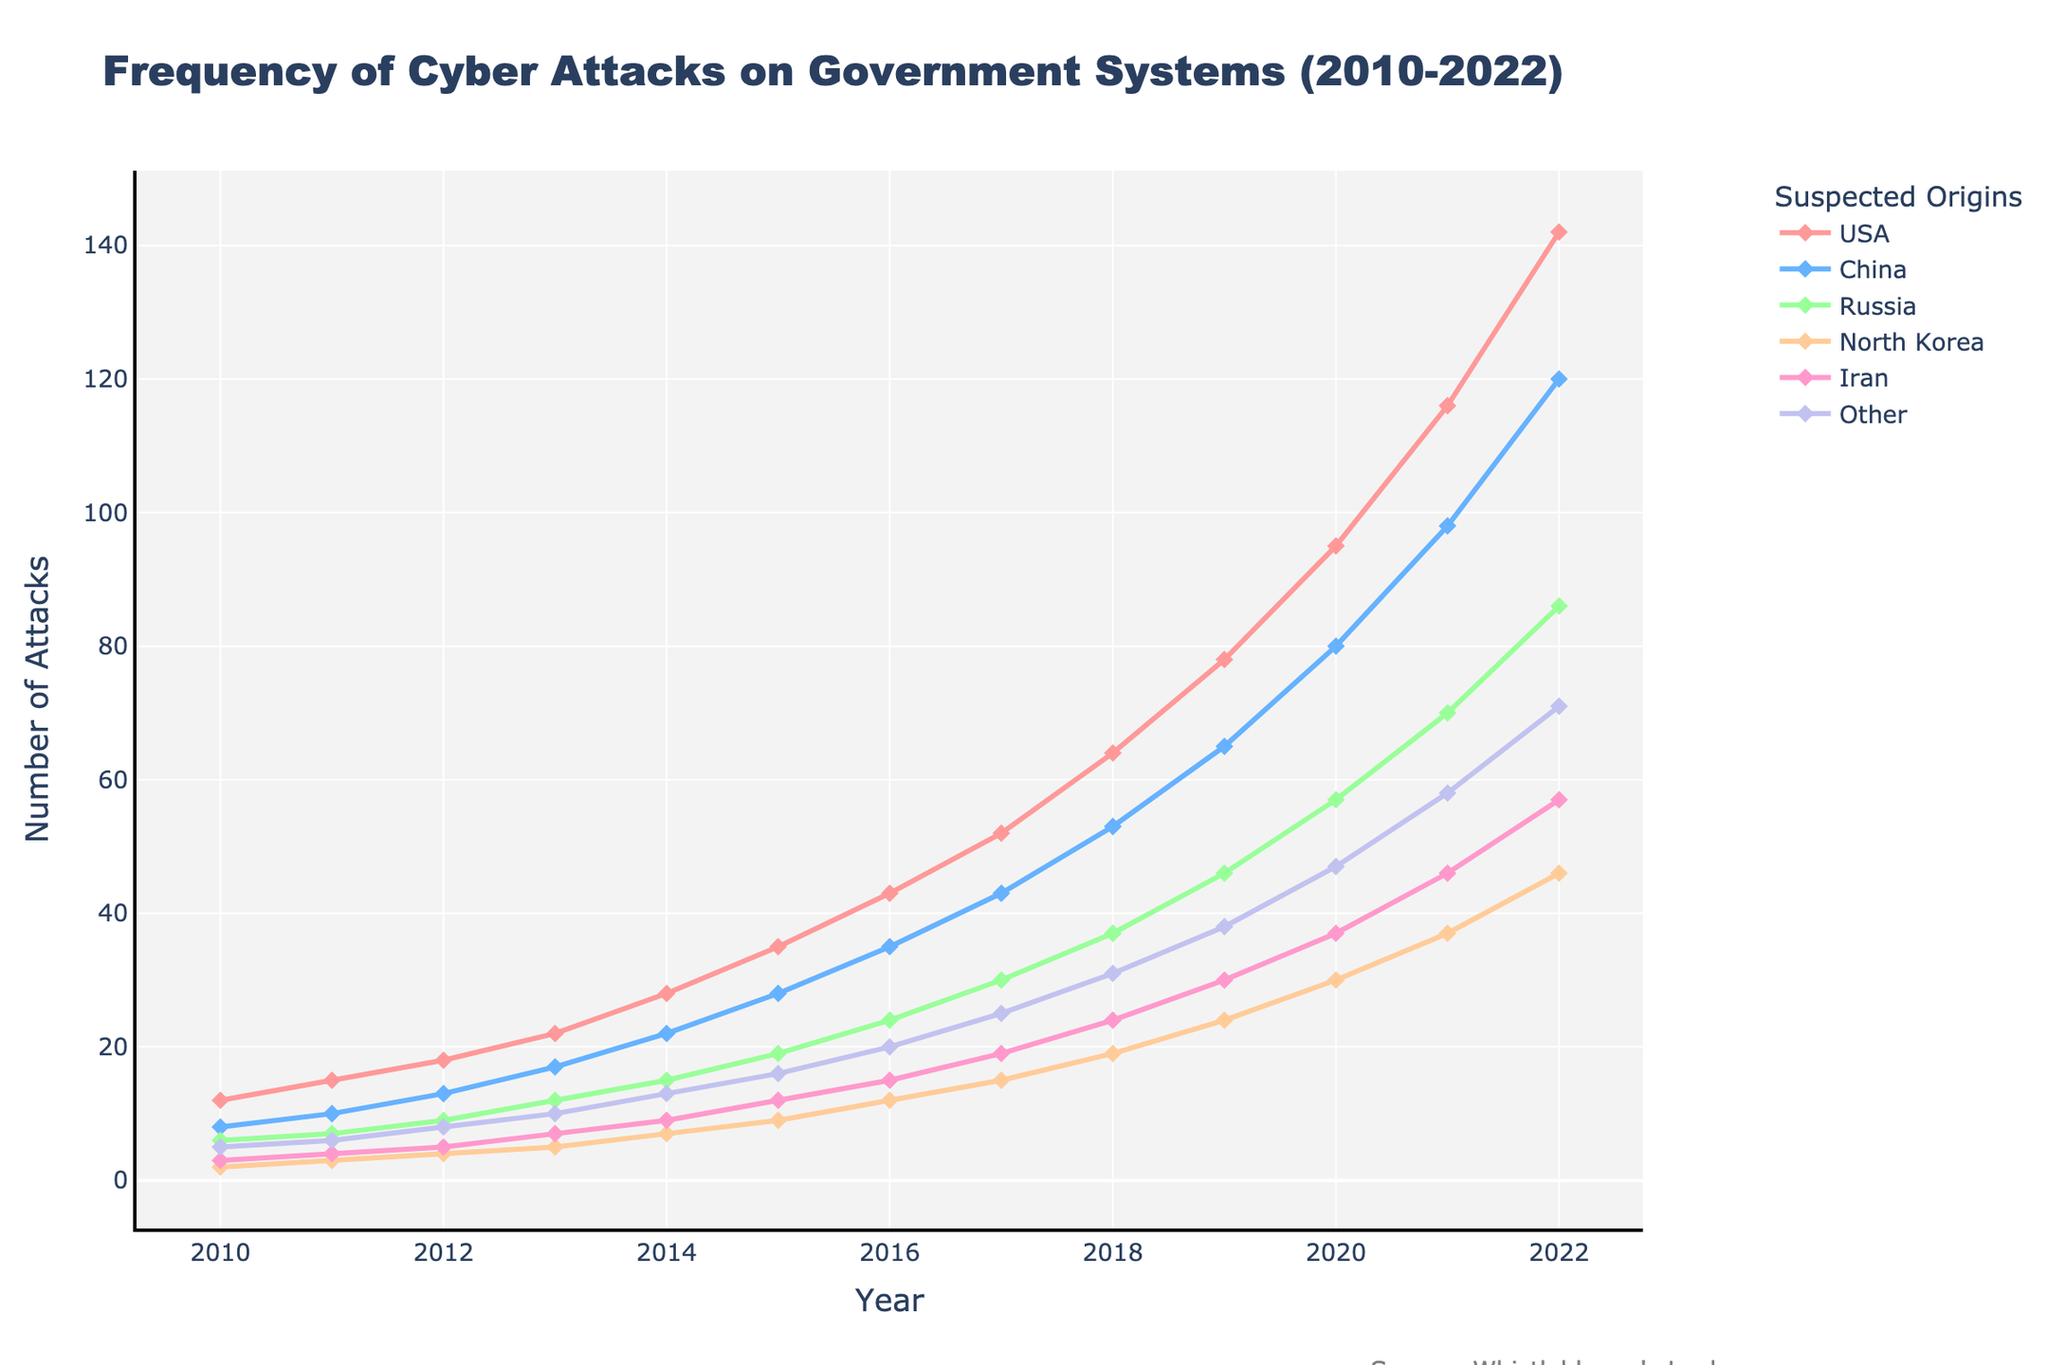Which country had the highest number of cyber attacks in 2022? The plot shows the number of attacks for each country in 2022 on the right-most side. The line labeled "USA" is the highest.
Answer: USA Between 2016 and 2018, which country showed the largest increase in the number of cyber attacks? To find the largest increase, subtract the number of attacks in 2016 from the number in 2018 for each country: USA (64-43=21), China (53-35=18), Russia (37-24=13), North Korea (19-12=7), Iran (24-15=9), Other (31-20=11). The USA has the largest increase at 21 attacks.
Answer: USA In which year did Iran surpass North Korea in the number of cyber attacks? To determine the year Iran surpassed North Korea, compare the values for each year. In 2019, Iran (30) had more attacks than North Korea (24) for the first time.
Answer: 2019 What is the average number of cyber attacks on government systems for Russia from 2010 to 2022? Add up all the values for Russia and divide by the number of years (13): (6+7+9+12+15+19+24+30+37+46+57+70+86)/13 ≈ 33.38
Answer: 33.38 Which country had the smallest variation in the frequency of cyber attacks between 2010 and 2022? Look at the visual plot and compare the fluctuations of each line. North Korea's line appears the flattest with the smallest increases, thus indicating the least variation.
Answer: North Korea In 2018, was the number of cyber attacks by "Other" origins higher, lower, or about the same as those by Iran in 2021? Compare the 'Other' line for 2018 (31) with the Iran line for 2021 (46). The attacks in 2018 by "Other" origins are lower than those by Iran in 2021.
Answer: Lower How did the gap in the number of cyber attacks between the USA and China change from 2011 to 2022? Calculate the gap for 2011 (15-10=5) and for 2022 (142-120=22). The gap increased from 5 to 22 over this period.
Answer: Increased What is the trend of cyber attacks on government systems by North Korea from 2010 to 2022? Analyze the North Korea line, which shows a gradual upward trend from 2 attacks in 2010 to 46 in 2022.
Answer: Gradual upward trend In which year did Russia experience its highest annual increase in cyber attacks? Examine the differences year by year for Russia: highest increase occurred between 2021 and 2022, where the number of attacks rose from 70 to 86, an increase of 16.
Answer: 2022 What is the difference in the number of cyber attacks between Iran and Russia in 2020? Subtract the number of attacks by Iran (37) from the number of attacks by Russia (57) in 2020: 57 - 37 = 20
Answer: 20 